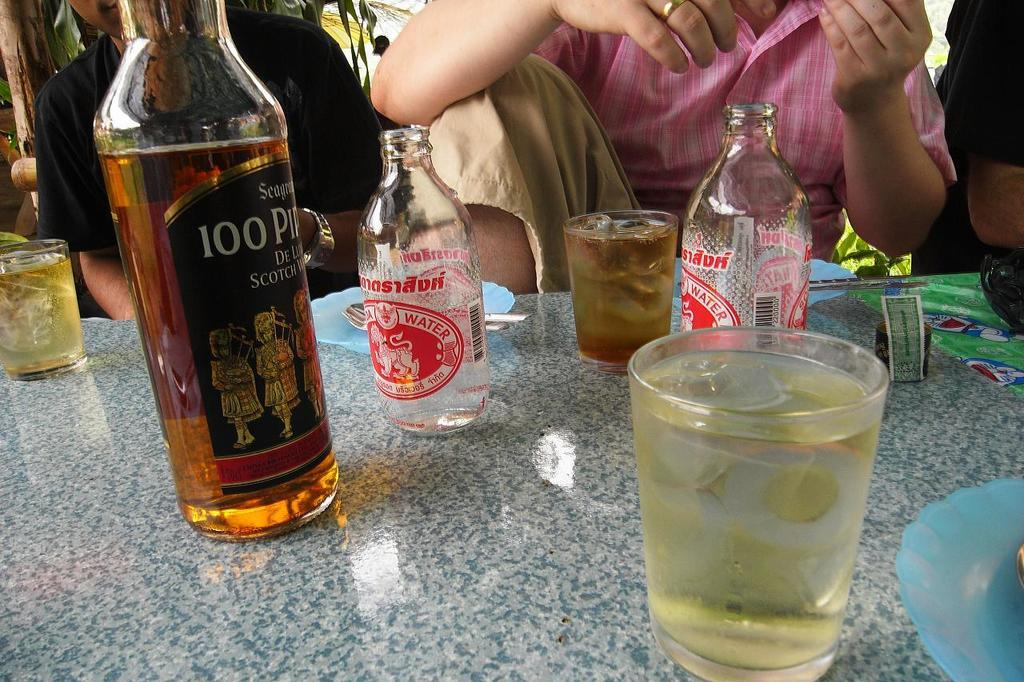Provide a one-sentence caption for the provided image. Bottle of alcohol with a label that says 100 on it. 